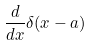<formula> <loc_0><loc_0><loc_500><loc_500>\frac { d } { d x } \delta ( x - a )</formula> 